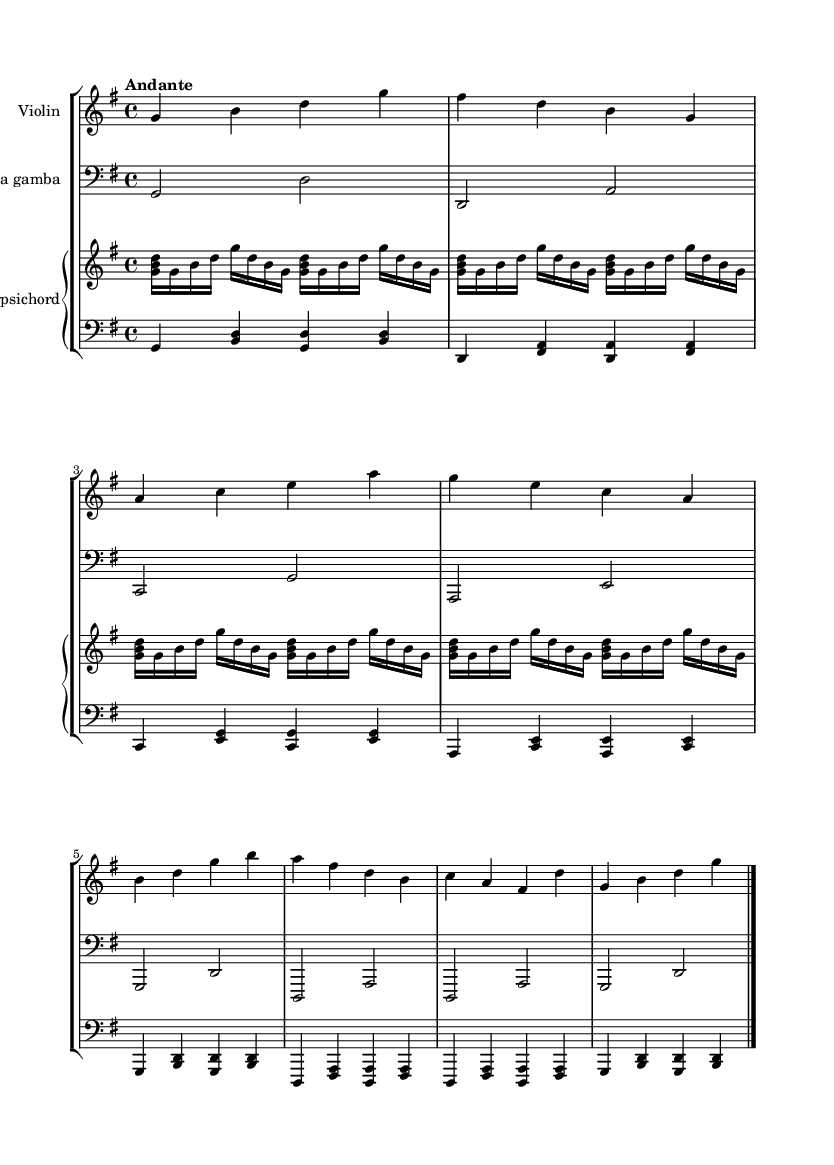What is the key signature of this music? The key signature is indicated by the sharp symbols on the staff at the beginning of the piece. In this case, there is one sharp (F#), which indicates that the piece is in G major.
Answer: G major What is the time signature of this music? The time signature is represented by the numbers at the beginning of the piece, directly after the key signature. Here, it shows 4 over 4, meaning there are 4 beats in each measure and the quarter note gets one beat.
Answer: 4/4 What is the tempo marking of this music? The tempo marking is written above the staff. It states "Andante," which indicates a moderate walking pace for the performance.
Answer: Andante How many measures are there in the violin part? By counting the groups of music between each bar line, we can tally the number of measures. The violin part has a total of 8 measures.
Answer: 8 How does the viola da gamba's melodic range compare to the violin? Observing the clef and the notes played, the viola da gamba uses a bass clef, indicating it plays lower pitches than the violin, which uses a treble clef. This suggests that the viola da gamba's range is lower than the violin.
Answer: Lower Which instruments are part of this chamber music ensemble? By looking at the score titles for each staff, we can determine which instruments are present. The score shows a violin, viola da gamba, and a harpsichord (with a right and a left staff).
Answer: Violin, viola da gamba, harpsichord What characteristic of Baroque music is exemplified by the use of harpsichord? The harpsichord is a keyboard instrument commonly used in Baroque music, characterized by its plucked strings. Its inclusion signifies the typical sound texture of the Baroque period, showcasing continuo playing.
Answer: Continuo 